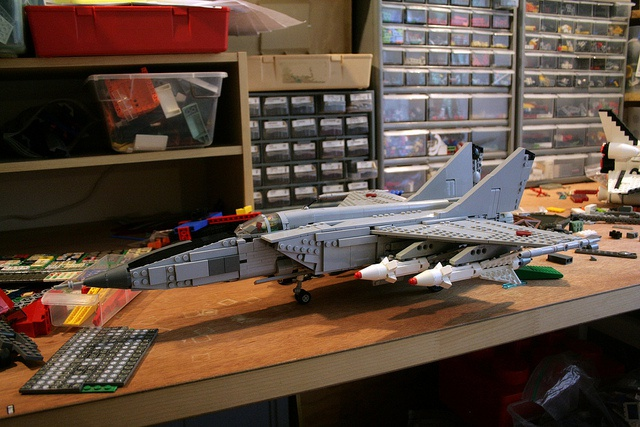Describe the objects in this image and their specific colors. I can see dining table in black, gray, brown, and maroon tones, airplane in black, gray, and darkgray tones, and keyboard in black, gray, and darkgray tones in this image. 